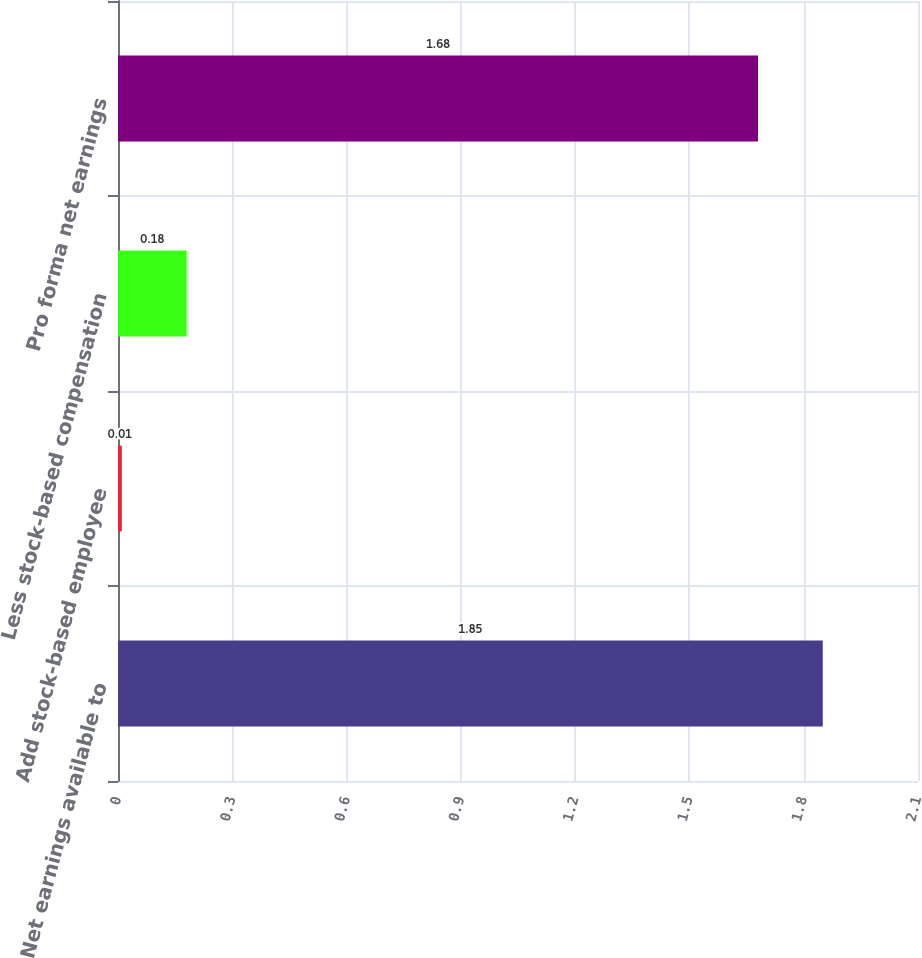<chart> <loc_0><loc_0><loc_500><loc_500><bar_chart><fcel>Net earnings available to<fcel>Add stock-based employee<fcel>Less stock-based compensation<fcel>Pro forma net earnings<nl><fcel>1.85<fcel>0.01<fcel>0.18<fcel>1.68<nl></chart> 